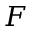Convert formula to latex. <formula><loc_0><loc_0><loc_500><loc_500>F</formula> 